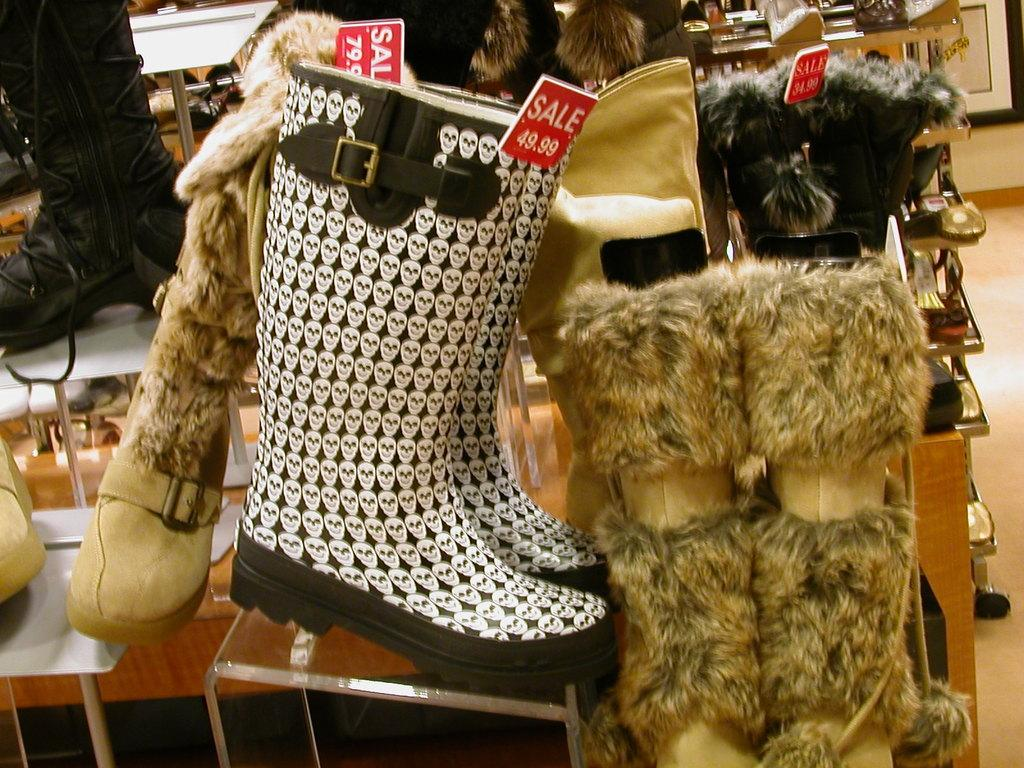What type of footwear is visible in the foreground of the image? There are boots with price tags in the foreground of the image. Can you describe the arrangement of the footwear in the background of the image? In the background of the image, there are shoes on tables and the floor. What type of fang can be seen in the image? There is no fang present in the image; it features footwear. How does the ray of light affect the appearance of the shoes in the image? There is no mention of a ray of light in the provided facts, so we cannot answer this question based on the image. 